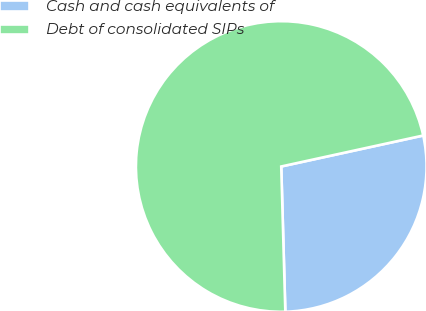Convert chart to OTSL. <chart><loc_0><loc_0><loc_500><loc_500><pie_chart><fcel>Cash and cash equivalents of<fcel>Debt of consolidated SIPs<nl><fcel>27.97%<fcel>72.03%<nl></chart> 